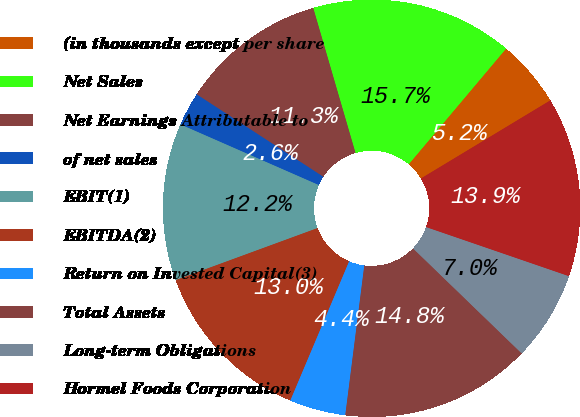<chart> <loc_0><loc_0><loc_500><loc_500><pie_chart><fcel>(in thousands except per share<fcel>Net Sales<fcel>Net Earnings Attributable to<fcel>of net sales<fcel>EBIT(1)<fcel>EBITDA(2)<fcel>Return on Invested Capital(3)<fcel>Total Assets<fcel>Long-term Obligations<fcel>Hormel Foods Corporation<nl><fcel>5.22%<fcel>15.65%<fcel>11.3%<fcel>2.61%<fcel>12.17%<fcel>13.04%<fcel>4.35%<fcel>14.78%<fcel>6.96%<fcel>13.91%<nl></chart> 